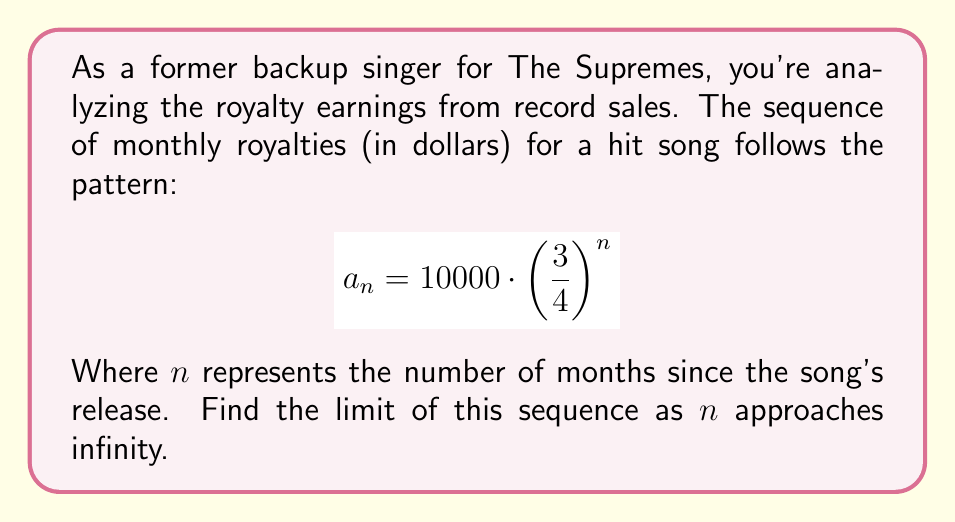Could you help me with this problem? Let's approach this step-by-step:

1) We're dealing with the sequence $a_n = 10000 \cdot \left(\frac{3}{4}\right)^n$

2) To find the limit as $n$ approaches infinity, we need to evaluate:
   $$\lim_{n \to \infty} 10000 \cdot \left(\frac{3}{4}\right)^n$$

3) We can factor out the constant:
   $$10000 \cdot \lim_{n \to \infty} \left(\frac{3}{4}\right)^n$$

4) Now, let's consider the limit of $\left(\frac{3}{4}\right)^n$ as $n$ approaches infinity:
   - $\frac{3}{4}$ is a fraction between 0 and 1
   - As $n$ gets larger, $\left(\frac{3}{4}\right)^n$ gets closer to 0

5) Therefore:
   $$\lim_{n \to \infty} \left(\frac{3}{4}\right)^n = 0$$

6) Substituting this back into our original limit:
   $$10000 \cdot \lim_{n \to \infty} \left(\frac{3}{4}\right)^n = 10000 \cdot 0 = 0$$

Thus, the limit of the sequence as $n$ approaches infinity is 0.
Answer: $0$ 